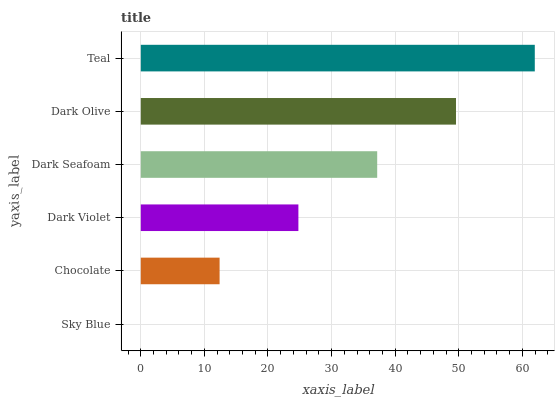Is Sky Blue the minimum?
Answer yes or no. Yes. Is Teal the maximum?
Answer yes or no. Yes. Is Chocolate the minimum?
Answer yes or no. No. Is Chocolate the maximum?
Answer yes or no. No. Is Chocolate greater than Sky Blue?
Answer yes or no. Yes. Is Sky Blue less than Chocolate?
Answer yes or no. Yes. Is Sky Blue greater than Chocolate?
Answer yes or no. No. Is Chocolate less than Sky Blue?
Answer yes or no. No. Is Dark Seafoam the high median?
Answer yes or no. Yes. Is Dark Violet the low median?
Answer yes or no. Yes. Is Teal the high median?
Answer yes or no. No. Is Chocolate the low median?
Answer yes or no. No. 